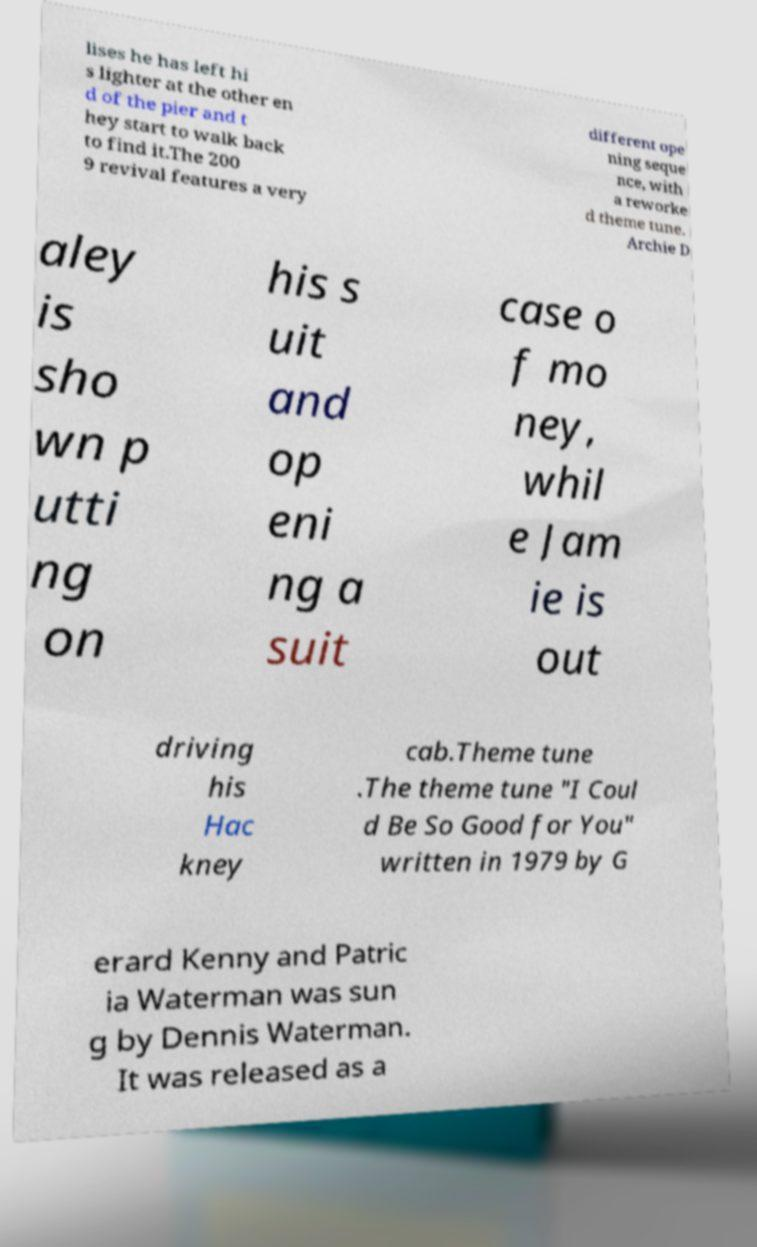For documentation purposes, I need the text within this image transcribed. Could you provide that? lises he has left hi s lighter at the other en d of the pier and t hey start to walk back to find it.The 200 9 revival features a very different ope ning seque nce, with a reworke d theme tune. Archie D aley is sho wn p utti ng on his s uit and op eni ng a suit case o f mo ney, whil e Jam ie is out driving his Hac kney cab.Theme tune .The theme tune "I Coul d Be So Good for You" written in 1979 by G erard Kenny and Patric ia Waterman was sun g by Dennis Waterman. It was released as a 